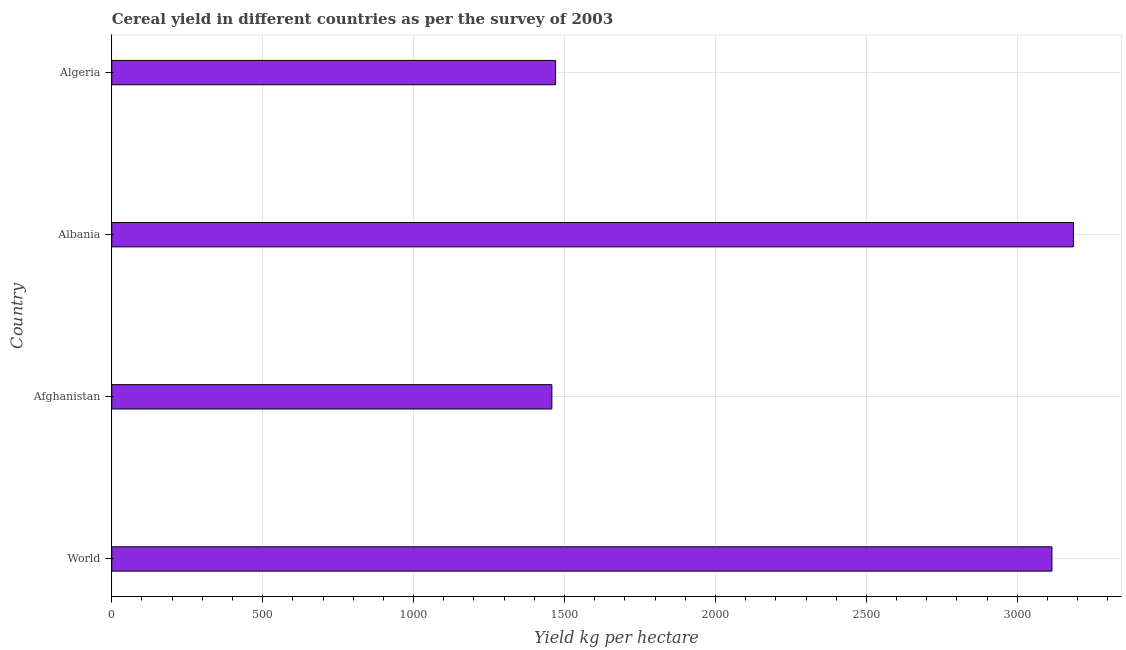Does the graph contain any zero values?
Offer a terse response. No. What is the title of the graph?
Keep it short and to the point. Cereal yield in different countries as per the survey of 2003. What is the label or title of the X-axis?
Give a very brief answer. Yield kg per hectare. What is the cereal yield in World?
Give a very brief answer. 3114.57. Across all countries, what is the maximum cereal yield?
Your response must be concise. 3185.73. Across all countries, what is the minimum cereal yield?
Your response must be concise. 1458.05. In which country was the cereal yield maximum?
Keep it short and to the point. Albania. In which country was the cereal yield minimum?
Your response must be concise. Afghanistan. What is the sum of the cereal yield?
Make the answer very short. 9228.69. What is the difference between the cereal yield in Albania and Algeria?
Ensure brevity in your answer.  1715.39. What is the average cereal yield per country?
Make the answer very short. 2307.17. What is the median cereal yield?
Make the answer very short. 2292.46. Is the difference between the cereal yield in Afghanistan and Algeria greater than the difference between any two countries?
Give a very brief answer. No. What is the difference between the highest and the second highest cereal yield?
Give a very brief answer. 71.16. What is the difference between the highest and the lowest cereal yield?
Ensure brevity in your answer.  1727.68. How many bars are there?
Your response must be concise. 4. How many countries are there in the graph?
Offer a very short reply. 4. Are the values on the major ticks of X-axis written in scientific E-notation?
Provide a succinct answer. No. What is the Yield kg per hectare of World?
Offer a terse response. 3114.57. What is the Yield kg per hectare in Afghanistan?
Provide a short and direct response. 1458.05. What is the Yield kg per hectare in Albania?
Keep it short and to the point. 3185.73. What is the Yield kg per hectare in Algeria?
Provide a succinct answer. 1470.34. What is the difference between the Yield kg per hectare in World and Afghanistan?
Provide a short and direct response. 1656.52. What is the difference between the Yield kg per hectare in World and Albania?
Keep it short and to the point. -71.16. What is the difference between the Yield kg per hectare in World and Algeria?
Offer a terse response. 1644.22. What is the difference between the Yield kg per hectare in Afghanistan and Albania?
Provide a succinct answer. -1727.68. What is the difference between the Yield kg per hectare in Afghanistan and Algeria?
Keep it short and to the point. -12.29. What is the difference between the Yield kg per hectare in Albania and Algeria?
Your answer should be very brief. 1715.39. What is the ratio of the Yield kg per hectare in World to that in Afghanistan?
Make the answer very short. 2.14. What is the ratio of the Yield kg per hectare in World to that in Albania?
Your answer should be very brief. 0.98. What is the ratio of the Yield kg per hectare in World to that in Algeria?
Keep it short and to the point. 2.12. What is the ratio of the Yield kg per hectare in Afghanistan to that in Albania?
Your answer should be compact. 0.46. What is the ratio of the Yield kg per hectare in Afghanistan to that in Algeria?
Your answer should be compact. 0.99. What is the ratio of the Yield kg per hectare in Albania to that in Algeria?
Give a very brief answer. 2.17. 